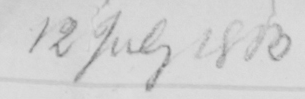What text is written in this handwritten line? 12 July 1803 